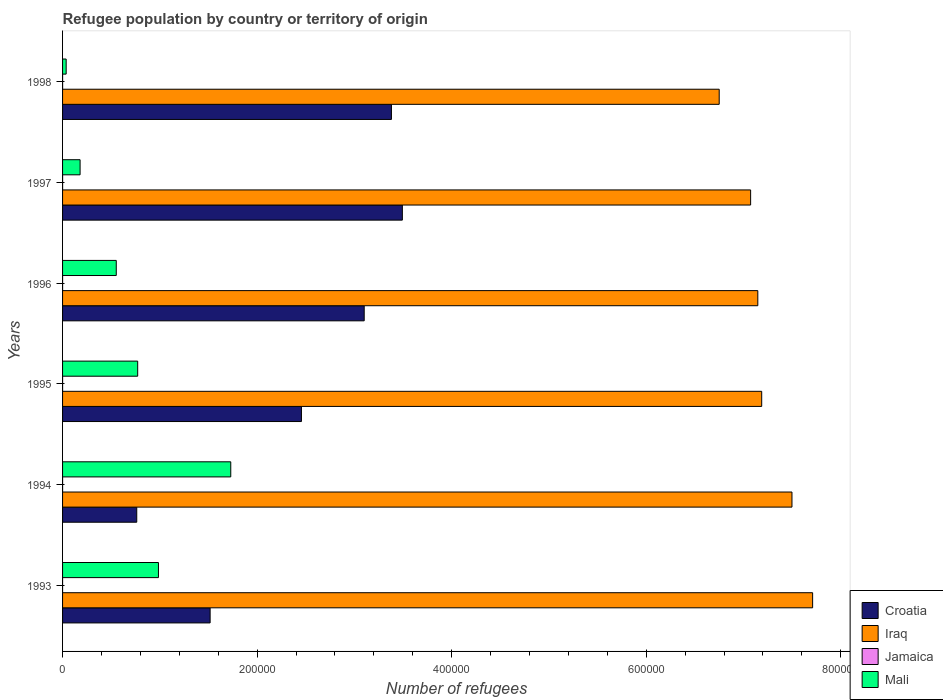How many different coloured bars are there?
Make the answer very short. 4. How many groups of bars are there?
Your answer should be compact. 6. Are the number of bars per tick equal to the number of legend labels?
Offer a very short reply. Yes. Are the number of bars on each tick of the Y-axis equal?
Your response must be concise. Yes. In how many cases, is the number of bars for a given year not equal to the number of legend labels?
Your response must be concise. 0. What is the number of refugees in Jamaica in 1993?
Make the answer very short. 3. Across all years, what is the maximum number of refugees in Iraq?
Your answer should be compact. 7.71e+05. Across all years, what is the minimum number of refugees in Croatia?
Your answer should be compact. 7.63e+04. What is the total number of refugees in Mali in the graph?
Provide a succinct answer. 4.26e+05. What is the difference between the number of refugees in Jamaica in 1997 and that in 1998?
Your response must be concise. -6. What is the difference between the number of refugees in Jamaica in 1996 and the number of refugees in Mali in 1998?
Provide a succinct answer. -3684. What is the average number of refugees in Iraq per year?
Give a very brief answer. 7.23e+05. In the year 1995, what is the difference between the number of refugees in Mali and number of refugees in Croatia?
Make the answer very short. -1.68e+05. In how many years, is the number of refugees in Iraq greater than 760000 ?
Your answer should be compact. 1. What is the ratio of the number of refugees in Croatia in 1993 to that in 1995?
Provide a succinct answer. 0.62. Is the number of refugees in Iraq in 1993 less than that in 1997?
Offer a very short reply. No. Is the difference between the number of refugees in Mali in 1993 and 1994 greater than the difference between the number of refugees in Croatia in 1993 and 1994?
Provide a short and direct response. No. What is the difference between the highest and the lowest number of refugees in Croatia?
Keep it short and to the point. 2.73e+05. Is the sum of the number of refugees in Croatia in 1995 and 1997 greater than the maximum number of refugees in Mali across all years?
Ensure brevity in your answer.  Yes. Is it the case that in every year, the sum of the number of refugees in Iraq and number of refugees in Croatia is greater than the sum of number of refugees in Jamaica and number of refugees in Mali?
Offer a very short reply. Yes. What does the 2nd bar from the top in 1993 represents?
Ensure brevity in your answer.  Jamaica. What does the 2nd bar from the bottom in 1993 represents?
Make the answer very short. Iraq. Is it the case that in every year, the sum of the number of refugees in Mali and number of refugees in Jamaica is greater than the number of refugees in Iraq?
Offer a very short reply. No. Are the values on the major ticks of X-axis written in scientific E-notation?
Offer a very short reply. No. Where does the legend appear in the graph?
Your answer should be very brief. Bottom right. How many legend labels are there?
Give a very brief answer. 4. What is the title of the graph?
Your answer should be very brief. Refugee population by country or territory of origin. What is the label or title of the X-axis?
Your answer should be very brief. Number of refugees. What is the label or title of the Y-axis?
Offer a very short reply. Years. What is the Number of refugees of Croatia in 1993?
Keep it short and to the point. 1.52e+05. What is the Number of refugees in Iraq in 1993?
Provide a short and direct response. 7.71e+05. What is the Number of refugees in Jamaica in 1993?
Give a very brief answer. 3. What is the Number of refugees of Mali in 1993?
Make the answer very short. 9.86e+04. What is the Number of refugees of Croatia in 1994?
Your answer should be very brief. 7.63e+04. What is the Number of refugees of Iraq in 1994?
Offer a terse response. 7.50e+05. What is the Number of refugees in Jamaica in 1994?
Ensure brevity in your answer.  7. What is the Number of refugees in Mali in 1994?
Offer a terse response. 1.73e+05. What is the Number of refugees of Croatia in 1995?
Your answer should be very brief. 2.46e+05. What is the Number of refugees in Iraq in 1995?
Keep it short and to the point. 7.19e+05. What is the Number of refugees in Jamaica in 1995?
Your answer should be compact. 10. What is the Number of refugees in Mali in 1995?
Offer a terse response. 7.72e+04. What is the Number of refugees in Croatia in 1996?
Give a very brief answer. 3.10e+05. What is the Number of refugees of Iraq in 1996?
Your answer should be very brief. 7.15e+05. What is the Number of refugees of Jamaica in 1996?
Give a very brief answer. 18. What is the Number of refugees in Mali in 1996?
Your response must be concise. 5.52e+04. What is the Number of refugees of Croatia in 1997?
Your answer should be compact. 3.49e+05. What is the Number of refugees in Iraq in 1997?
Provide a short and direct response. 7.07e+05. What is the Number of refugees of Jamaica in 1997?
Give a very brief answer. 21. What is the Number of refugees of Mali in 1997?
Your answer should be very brief. 1.80e+04. What is the Number of refugees in Croatia in 1998?
Your answer should be compact. 3.38e+05. What is the Number of refugees of Iraq in 1998?
Provide a succinct answer. 6.75e+05. What is the Number of refugees of Jamaica in 1998?
Offer a very short reply. 27. What is the Number of refugees of Mali in 1998?
Give a very brief answer. 3702. Across all years, what is the maximum Number of refugees of Croatia?
Your response must be concise. 3.49e+05. Across all years, what is the maximum Number of refugees in Iraq?
Your answer should be compact. 7.71e+05. Across all years, what is the maximum Number of refugees in Mali?
Keep it short and to the point. 1.73e+05. Across all years, what is the minimum Number of refugees of Croatia?
Offer a very short reply. 7.63e+04. Across all years, what is the minimum Number of refugees of Iraq?
Keep it short and to the point. 6.75e+05. Across all years, what is the minimum Number of refugees of Jamaica?
Keep it short and to the point. 3. Across all years, what is the minimum Number of refugees of Mali?
Ensure brevity in your answer.  3702. What is the total Number of refugees in Croatia in the graph?
Your answer should be compact. 1.47e+06. What is the total Number of refugees of Iraq in the graph?
Provide a succinct answer. 4.34e+06. What is the total Number of refugees of Mali in the graph?
Provide a short and direct response. 4.26e+05. What is the difference between the Number of refugees in Croatia in 1993 and that in 1994?
Your answer should be compact. 7.54e+04. What is the difference between the Number of refugees in Iraq in 1993 and that in 1994?
Your answer should be compact. 2.12e+04. What is the difference between the Number of refugees in Jamaica in 1993 and that in 1994?
Your answer should be very brief. -4. What is the difference between the Number of refugees in Mali in 1993 and that in 1994?
Offer a very short reply. -7.43e+04. What is the difference between the Number of refugees in Croatia in 1993 and that in 1995?
Provide a succinct answer. -9.39e+04. What is the difference between the Number of refugees of Iraq in 1993 and that in 1995?
Your answer should be compact. 5.24e+04. What is the difference between the Number of refugees in Jamaica in 1993 and that in 1995?
Your response must be concise. -7. What is the difference between the Number of refugees of Mali in 1993 and that in 1995?
Give a very brief answer. 2.14e+04. What is the difference between the Number of refugees of Croatia in 1993 and that in 1996?
Your answer should be very brief. -1.58e+05. What is the difference between the Number of refugees in Iraq in 1993 and that in 1996?
Offer a very short reply. 5.63e+04. What is the difference between the Number of refugees in Jamaica in 1993 and that in 1996?
Make the answer very short. -15. What is the difference between the Number of refugees of Mali in 1993 and that in 1996?
Your answer should be compact. 4.34e+04. What is the difference between the Number of refugees of Croatia in 1993 and that in 1997?
Keep it short and to the point. -1.98e+05. What is the difference between the Number of refugees in Iraq in 1993 and that in 1997?
Offer a very short reply. 6.37e+04. What is the difference between the Number of refugees of Mali in 1993 and that in 1997?
Give a very brief answer. 8.06e+04. What is the difference between the Number of refugees in Croatia in 1993 and that in 1998?
Give a very brief answer. -1.86e+05. What is the difference between the Number of refugees of Iraq in 1993 and that in 1998?
Offer a very short reply. 9.60e+04. What is the difference between the Number of refugees in Mali in 1993 and that in 1998?
Your response must be concise. 9.49e+04. What is the difference between the Number of refugees in Croatia in 1994 and that in 1995?
Provide a short and direct response. -1.69e+05. What is the difference between the Number of refugees in Iraq in 1994 and that in 1995?
Make the answer very short. 3.11e+04. What is the difference between the Number of refugees of Jamaica in 1994 and that in 1995?
Give a very brief answer. -3. What is the difference between the Number of refugees in Mali in 1994 and that in 1995?
Offer a terse response. 9.57e+04. What is the difference between the Number of refugees in Croatia in 1994 and that in 1996?
Make the answer very short. -2.34e+05. What is the difference between the Number of refugees of Iraq in 1994 and that in 1996?
Provide a succinct answer. 3.51e+04. What is the difference between the Number of refugees of Jamaica in 1994 and that in 1996?
Your response must be concise. -11. What is the difference between the Number of refugees of Mali in 1994 and that in 1996?
Your answer should be compact. 1.18e+05. What is the difference between the Number of refugees of Croatia in 1994 and that in 1997?
Offer a very short reply. -2.73e+05. What is the difference between the Number of refugees of Iraq in 1994 and that in 1997?
Provide a succinct answer. 4.25e+04. What is the difference between the Number of refugees in Mali in 1994 and that in 1997?
Your answer should be compact. 1.55e+05. What is the difference between the Number of refugees of Croatia in 1994 and that in 1998?
Offer a very short reply. -2.62e+05. What is the difference between the Number of refugees of Iraq in 1994 and that in 1998?
Keep it short and to the point. 7.48e+04. What is the difference between the Number of refugees in Jamaica in 1994 and that in 1998?
Give a very brief answer. -20. What is the difference between the Number of refugees of Mali in 1994 and that in 1998?
Provide a short and direct response. 1.69e+05. What is the difference between the Number of refugees of Croatia in 1995 and that in 1996?
Ensure brevity in your answer.  -6.45e+04. What is the difference between the Number of refugees in Iraq in 1995 and that in 1996?
Make the answer very short. 3989. What is the difference between the Number of refugees of Jamaica in 1995 and that in 1996?
Give a very brief answer. -8. What is the difference between the Number of refugees of Mali in 1995 and that in 1996?
Ensure brevity in your answer.  2.20e+04. What is the difference between the Number of refugees of Croatia in 1995 and that in 1997?
Provide a succinct answer. -1.04e+05. What is the difference between the Number of refugees in Iraq in 1995 and that in 1997?
Offer a terse response. 1.14e+04. What is the difference between the Number of refugees in Mali in 1995 and that in 1997?
Keep it short and to the point. 5.92e+04. What is the difference between the Number of refugees of Croatia in 1995 and that in 1998?
Your answer should be compact. -9.25e+04. What is the difference between the Number of refugees of Iraq in 1995 and that in 1998?
Ensure brevity in your answer.  4.37e+04. What is the difference between the Number of refugees in Mali in 1995 and that in 1998?
Ensure brevity in your answer.  7.35e+04. What is the difference between the Number of refugees in Croatia in 1996 and that in 1997?
Make the answer very short. -3.92e+04. What is the difference between the Number of refugees in Iraq in 1996 and that in 1997?
Provide a short and direct response. 7392. What is the difference between the Number of refugees in Mali in 1996 and that in 1997?
Your response must be concise. 3.72e+04. What is the difference between the Number of refugees of Croatia in 1996 and that in 1998?
Your response must be concise. -2.80e+04. What is the difference between the Number of refugees in Iraq in 1996 and that in 1998?
Your answer should be very brief. 3.97e+04. What is the difference between the Number of refugees in Mali in 1996 and that in 1998?
Provide a short and direct response. 5.15e+04. What is the difference between the Number of refugees of Croatia in 1997 and that in 1998?
Your answer should be very brief. 1.12e+04. What is the difference between the Number of refugees of Iraq in 1997 and that in 1998?
Keep it short and to the point. 3.23e+04. What is the difference between the Number of refugees of Mali in 1997 and that in 1998?
Make the answer very short. 1.43e+04. What is the difference between the Number of refugees of Croatia in 1993 and the Number of refugees of Iraq in 1994?
Ensure brevity in your answer.  -5.98e+05. What is the difference between the Number of refugees of Croatia in 1993 and the Number of refugees of Jamaica in 1994?
Your response must be concise. 1.52e+05. What is the difference between the Number of refugees in Croatia in 1993 and the Number of refugees in Mali in 1994?
Provide a short and direct response. -2.12e+04. What is the difference between the Number of refugees in Iraq in 1993 and the Number of refugees in Jamaica in 1994?
Make the answer very short. 7.71e+05. What is the difference between the Number of refugees in Iraq in 1993 and the Number of refugees in Mali in 1994?
Give a very brief answer. 5.98e+05. What is the difference between the Number of refugees of Jamaica in 1993 and the Number of refugees of Mali in 1994?
Keep it short and to the point. -1.73e+05. What is the difference between the Number of refugees in Croatia in 1993 and the Number of refugees in Iraq in 1995?
Offer a terse response. -5.67e+05. What is the difference between the Number of refugees in Croatia in 1993 and the Number of refugees in Jamaica in 1995?
Your answer should be very brief. 1.52e+05. What is the difference between the Number of refugees in Croatia in 1993 and the Number of refugees in Mali in 1995?
Offer a very short reply. 7.45e+04. What is the difference between the Number of refugees in Iraq in 1993 and the Number of refugees in Jamaica in 1995?
Provide a succinct answer. 7.71e+05. What is the difference between the Number of refugees of Iraq in 1993 and the Number of refugees of Mali in 1995?
Offer a very short reply. 6.94e+05. What is the difference between the Number of refugees in Jamaica in 1993 and the Number of refugees in Mali in 1995?
Keep it short and to the point. -7.72e+04. What is the difference between the Number of refugees of Croatia in 1993 and the Number of refugees of Iraq in 1996?
Give a very brief answer. -5.63e+05. What is the difference between the Number of refugees of Croatia in 1993 and the Number of refugees of Jamaica in 1996?
Your response must be concise. 1.52e+05. What is the difference between the Number of refugees of Croatia in 1993 and the Number of refugees of Mali in 1996?
Offer a very short reply. 9.65e+04. What is the difference between the Number of refugees in Iraq in 1993 and the Number of refugees in Jamaica in 1996?
Provide a succinct answer. 7.71e+05. What is the difference between the Number of refugees in Iraq in 1993 and the Number of refugees in Mali in 1996?
Give a very brief answer. 7.16e+05. What is the difference between the Number of refugees in Jamaica in 1993 and the Number of refugees in Mali in 1996?
Your response must be concise. -5.52e+04. What is the difference between the Number of refugees of Croatia in 1993 and the Number of refugees of Iraq in 1997?
Ensure brevity in your answer.  -5.56e+05. What is the difference between the Number of refugees in Croatia in 1993 and the Number of refugees in Jamaica in 1997?
Provide a succinct answer. 1.52e+05. What is the difference between the Number of refugees of Croatia in 1993 and the Number of refugees of Mali in 1997?
Offer a terse response. 1.34e+05. What is the difference between the Number of refugees in Iraq in 1993 and the Number of refugees in Jamaica in 1997?
Provide a succinct answer. 7.71e+05. What is the difference between the Number of refugees of Iraq in 1993 and the Number of refugees of Mali in 1997?
Your answer should be very brief. 7.53e+05. What is the difference between the Number of refugees in Jamaica in 1993 and the Number of refugees in Mali in 1997?
Your answer should be very brief. -1.80e+04. What is the difference between the Number of refugees of Croatia in 1993 and the Number of refugees of Iraq in 1998?
Your response must be concise. -5.23e+05. What is the difference between the Number of refugees of Croatia in 1993 and the Number of refugees of Jamaica in 1998?
Offer a very short reply. 1.52e+05. What is the difference between the Number of refugees in Croatia in 1993 and the Number of refugees in Mali in 1998?
Offer a terse response. 1.48e+05. What is the difference between the Number of refugees of Iraq in 1993 and the Number of refugees of Jamaica in 1998?
Make the answer very short. 7.71e+05. What is the difference between the Number of refugees in Iraq in 1993 and the Number of refugees in Mali in 1998?
Give a very brief answer. 7.67e+05. What is the difference between the Number of refugees in Jamaica in 1993 and the Number of refugees in Mali in 1998?
Offer a very short reply. -3699. What is the difference between the Number of refugees of Croatia in 1994 and the Number of refugees of Iraq in 1995?
Your response must be concise. -6.42e+05. What is the difference between the Number of refugees in Croatia in 1994 and the Number of refugees in Jamaica in 1995?
Your response must be concise. 7.62e+04. What is the difference between the Number of refugees of Croatia in 1994 and the Number of refugees of Mali in 1995?
Provide a succinct answer. -963. What is the difference between the Number of refugees in Iraq in 1994 and the Number of refugees in Jamaica in 1995?
Your answer should be very brief. 7.50e+05. What is the difference between the Number of refugees of Iraq in 1994 and the Number of refugees of Mali in 1995?
Your answer should be very brief. 6.73e+05. What is the difference between the Number of refugees in Jamaica in 1994 and the Number of refugees in Mali in 1995?
Your response must be concise. -7.72e+04. What is the difference between the Number of refugees in Croatia in 1994 and the Number of refugees in Iraq in 1996?
Your response must be concise. -6.38e+05. What is the difference between the Number of refugees in Croatia in 1994 and the Number of refugees in Jamaica in 1996?
Offer a very short reply. 7.62e+04. What is the difference between the Number of refugees in Croatia in 1994 and the Number of refugees in Mali in 1996?
Your answer should be compact. 2.11e+04. What is the difference between the Number of refugees in Iraq in 1994 and the Number of refugees in Jamaica in 1996?
Make the answer very short. 7.50e+05. What is the difference between the Number of refugees in Iraq in 1994 and the Number of refugees in Mali in 1996?
Keep it short and to the point. 6.95e+05. What is the difference between the Number of refugees in Jamaica in 1994 and the Number of refugees in Mali in 1996?
Provide a short and direct response. -5.52e+04. What is the difference between the Number of refugees in Croatia in 1994 and the Number of refugees in Iraq in 1997?
Ensure brevity in your answer.  -6.31e+05. What is the difference between the Number of refugees in Croatia in 1994 and the Number of refugees in Jamaica in 1997?
Keep it short and to the point. 7.62e+04. What is the difference between the Number of refugees in Croatia in 1994 and the Number of refugees in Mali in 1997?
Provide a succinct answer. 5.82e+04. What is the difference between the Number of refugees of Iraq in 1994 and the Number of refugees of Jamaica in 1997?
Keep it short and to the point. 7.50e+05. What is the difference between the Number of refugees in Iraq in 1994 and the Number of refugees in Mali in 1997?
Provide a short and direct response. 7.32e+05. What is the difference between the Number of refugees of Jamaica in 1994 and the Number of refugees of Mali in 1997?
Provide a succinct answer. -1.80e+04. What is the difference between the Number of refugees of Croatia in 1994 and the Number of refugees of Iraq in 1998?
Provide a succinct answer. -5.99e+05. What is the difference between the Number of refugees in Croatia in 1994 and the Number of refugees in Jamaica in 1998?
Your response must be concise. 7.62e+04. What is the difference between the Number of refugees in Croatia in 1994 and the Number of refugees in Mali in 1998?
Make the answer very short. 7.26e+04. What is the difference between the Number of refugees of Iraq in 1994 and the Number of refugees of Jamaica in 1998?
Give a very brief answer. 7.50e+05. What is the difference between the Number of refugees of Iraq in 1994 and the Number of refugees of Mali in 1998?
Your response must be concise. 7.46e+05. What is the difference between the Number of refugees of Jamaica in 1994 and the Number of refugees of Mali in 1998?
Provide a succinct answer. -3695. What is the difference between the Number of refugees in Croatia in 1995 and the Number of refugees in Iraq in 1996?
Keep it short and to the point. -4.69e+05. What is the difference between the Number of refugees in Croatia in 1995 and the Number of refugees in Jamaica in 1996?
Make the answer very short. 2.46e+05. What is the difference between the Number of refugees of Croatia in 1995 and the Number of refugees of Mali in 1996?
Provide a short and direct response. 1.90e+05. What is the difference between the Number of refugees in Iraq in 1995 and the Number of refugees in Jamaica in 1996?
Your response must be concise. 7.19e+05. What is the difference between the Number of refugees of Iraq in 1995 and the Number of refugees of Mali in 1996?
Give a very brief answer. 6.64e+05. What is the difference between the Number of refugees of Jamaica in 1995 and the Number of refugees of Mali in 1996?
Keep it short and to the point. -5.52e+04. What is the difference between the Number of refugees in Croatia in 1995 and the Number of refugees in Iraq in 1997?
Ensure brevity in your answer.  -4.62e+05. What is the difference between the Number of refugees in Croatia in 1995 and the Number of refugees in Jamaica in 1997?
Make the answer very short. 2.46e+05. What is the difference between the Number of refugees in Croatia in 1995 and the Number of refugees in Mali in 1997?
Provide a succinct answer. 2.28e+05. What is the difference between the Number of refugees in Iraq in 1995 and the Number of refugees in Jamaica in 1997?
Give a very brief answer. 7.19e+05. What is the difference between the Number of refugees of Iraq in 1995 and the Number of refugees of Mali in 1997?
Your answer should be very brief. 7.01e+05. What is the difference between the Number of refugees in Jamaica in 1995 and the Number of refugees in Mali in 1997?
Give a very brief answer. -1.80e+04. What is the difference between the Number of refugees in Croatia in 1995 and the Number of refugees in Iraq in 1998?
Give a very brief answer. -4.29e+05. What is the difference between the Number of refugees in Croatia in 1995 and the Number of refugees in Jamaica in 1998?
Keep it short and to the point. 2.46e+05. What is the difference between the Number of refugees in Croatia in 1995 and the Number of refugees in Mali in 1998?
Provide a succinct answer. 2.42e+05. What is the difference between the Number of refugees in Iraq in 1995 and the Number of refugees in Jamaica in 1998?
Your answer should be compact. 7.19e+05. What is the difference between the Number of refugees of Iraq in 1995 and the Number of refugees of Mali in 1998?
Provide a short and direct response. 7.15e+05. What is the difference between the Number of refugees in Jamaica in 1995 and the Number of refugees in Mali in 1998?
Keep it short and to the point. -3692. What is the difference between the Number of refugees in Croatia in 1996 and the Number of refugees in Iraq in 1997?
Offer a terse response. -3.97e+05. What is the difference between the Number of refugees in Croatia in 1996 and the Number of refugees in Jamaica in 1997?
Provide a short and direct response. 3.10e+05. What is the difference between the Number of refugees in Croatia in 1996 and the Number of refugees in Mali in 1997?
Give a very brief answer. 2.92e+05. What is the difference between the Number of refugees of Iraq in 1996 and the Number of refugees of Jamaica in 1997?
Provide a short and direct response. 7.15e+05. What is the difference between the Number of refugees of Iraq in 1996 and the Number of refugees of Mali in 1997?
Your response must be concise. 6.97e+05. What is the difference between the Number of refugees in Jamaica in 1996 and the Number of refugees in Mali in 1997?
Ensure brevity in your answer.  -1.80e+04. What is the difference between the Number of refugees in Croatia in 1996 and the Number of refugees in Iraq in 1998?
Your answer should be very brief. -3.65e+05. What is the difference between the Number of refugees of Croatia in 1996 and the Number of refugees of Jamaica in 1998?
Provide a short and direct response. 3.10e+05. What is the difference between the Number of refugees in Croatia in 1996 and the Number of refugees in Mali in 1998?
Make the answer very short. 3.06e+05. What is the difference between the Number of refugees of Iraq in 1996 and the Number of refugees of Jamaica in 1998?
Ensure brevity in your answer.  7.15e+05. What is the difference between the Number of refugees in Iraq in 1996 and the Number of refugees in Mali in 1998?
Offer a very short reply. 7.11e+05. What is the difference between the Number of refugees in Jamaica in 1996 and the Number of refugees in Mali in 1998?
Your response must be concise. -3684. What is the difference between the Number of refugees of Croatia in 1997 and the Number of refugees of Iraq in 1998?
Give a very brief answer. -3.26e+05. What is the difference between the Number of refugees of Croatia in 1997 and the Number of refugees of Jamaica in 1998?
Keep it short and to the point. 3.49e+05. What is the difference between the Number of refugees of Croatia in 1997 and the Number of refugees of Mali in 1998?
Your answer should be compact. 3.46e+05. What is the difference between the Number of refugees of Iraq in 1997 and the Number of refugees of Jamaica in 1998?
Offer a terse response. 7.07e+05. What is the difference between the Number of refugees of Iraq in 1997 and the Number of refugees of Mali in 1998?
Make the answer very short. 7.04e+05. What is the difference between the Number of refugees in Jamaica in 1997 and the Number of refugees in Mali in 1998?
Ensure brevity in your answer.  -3681. What is the average Number of refugees of Croatia per year?
Your answer should be very brief. 2.45e+05. What is the average Number of refugees in Iraq per year?
Provide a succinct answer. 7.23e+05. What is the average Number of refugees of Jamaica per year?
Offer a very short reply. 14.33. What is the average Number of refugees in Mali per year?
Make the answer very short. 7.09e+04. In the year 1993, what is the difference between the Number of refugees of Croatia and Number of refugees of Iraq?
Offer a terse response. -6.19e+05. In the year 1993, what is the difference between the Number of refugees of Croatia and Number of refugees of Jamaica?
Ensure brevity in your answer.  1.52e+05. In the year 1993, what is the difference between the Number of refugees of Croatia and Number of refugees of Mali?
Give a very brief answer. 5.31e+04. In the year 1993, what is the difference between the Number of refugees in Iraq and Number of refugees in Jamaica?
Your answer should be compact. 7.71e+05. In the year 1993, what is the difference between the Number of refugees of Iraq and Number of refugees of Mali?
Offer a terse response. 6.73e+05. In the year 1993, what is the difference between the Number of refugees in Jamaica and Number of refugees in Mali?
Make the answer very short. -9.86e+04. In the year 1994, what is the difference between the Number of refugees of Croatia and Number of refugees of Iraq?
Offer a very short reply. -6.74e+05. In the year 1994, what is the difference between the Number of refugees in Croatia and Number of refugees in Jamaica?
Offer a very short reply. 7.62e+04. In the year 1994, what is the difference between the Number of refugees of Croatia and Number of refugees of Mali?
Offer a terse response. -9.66e+04. In the year 1994, what is the difference between the Number of refugees in Iraq and Number of refugees in Jamaica?
Your answer should be very brief. 7.50e+05. In the year 1994, what is the difference between the Number of refugees of Iraq and Number of refugees of Mali?
Ensure brevity in your answer.  5.77e+05. In the year 1994, what is the difference between the Number of refugees of Jamaica and Number of refugees of Mali?
Your answer should be very brief. -1.73e+05. In the year 1995, what is the difference between the Number of refugees in Croatia and Number of refugees in Iraq?
Provide a succinct answer. -4.73e+05. In the year 1995, what is the difference between the Number of refugees in Croatia and Number of refugees in Jamaica?
Offer a very short reply. 2.46e+05. In the year 1995, what is the difference between the Number of refugees in Croatia and Number of refugees in Mali?
Give a very brief answer. 1.68e+05. In the year 1995, what is the difference between the Number of refugees of Iraq and Number of refugees of Jamaica?
Provide a short and direct response. 7.19e+05. In the year 1995, what is the difference between the Number of refugees of Iraq and Number of refugees of Mali?
Provide a short and direct response. 6.42e+05. In the year 1995, what is the difference between the Number of refugees in Jamaica and Number of refugees in Mali?
Offer a terse response. -7.72e+04. In the year 1996, what is the difference between the Number of refugees of Croatia and Number of refugees of Iraq?
Offer a terse response. -4.05e+05. In the year 1996, what is the difference between the Number of refugees in Croatia and Number of refugees in Jamaica?
Keep it short and to the point. 3.10e+05. In the year 1996, what is the difference between the Number of refugees in Croatia and Number of refugees in Mali?
Give a very brief answer. 2.55e+05. In the year 1996, what is the difference between the Number of refugees of Iraq and Number of refugees of Jamaica?
Give a very brief answer. 7.15e+05. In the year 1996, what is the difference between the Number of refugees in Iraq and Number of refugees in Mali?
Ensure brevity in your answer.  6.60e+05. In the year 1996, what is the difference between the Number of refugees of Jamaica and Number of refugees of Mali?
Offer a terse response. -5.52e+04. In the year 1997, what is the difference between the Number of refugees of Croatia and Number of refugees of Iraq?
Ensure brevity in your answer.  -3.58e+05. In the year 1997, what is the difference between the Number of refugees in Croatia and Number of refugees in Jamaica?
Keep it short and to the point. 3.49e+05. In the year 1997, what is the difference between the Number of refugees in Croatia and Number of refugees in Mali?
Provide a succinct answer. 3.31e+05. In the year 1997, what is the difference between the Number of refugees in Iraq and Number of refugees in Jamaica?
Provide a succinct answer. 7.07e+05. In the year 1997, what is the difference between the Number of refugees in Iraq and Number of refugees in Mali?
Offer a terse response. 6.89e+05. In the year 1997, what is the difference between the Number of refugees of Jamaica and Number of refugees of Mali?
Ensure brevity in your answer.  -1.80e+04. In the year 1998, what is the difference between the Number of refugees of Croatia and Number of refugees of Iraq?
Your response must be concise. -3.37e+05. In the year 1998, what is the difference between the Number of refugees in Croatia and Number of refugees in Jamaica?
Keep it short and to the point. 3.38e+05. In the year 1998, what is the difference between the Number of refugees of Croatia and Number of refugees of Mali?
Your response must be concise. 3.34e+05. In the year 1998, what is the difference between the Number of refugees of Iraq and Number of refugees of Jamaica?
Your answer should be compact. 6.75e+05. In the year 1998, what is the difference between the Number of refugees of Iraq and Number of refugees of Mali?
Provide a short and direct response. 6.71e+05. In the year 1998, what is the difference between the Number of refugees of Jamaica and Number of refugees of Mali?
Give a very brief answer. -3675. What is the ratio of the Number of refugees in Croatia in 1993 to that in 1994?
Keep it short and to the point. 1.99. What is the ratio of the Number of refugees of Iraq in 1993 to that in 1994?
Your answer should be very brief. 1.03. What is the ratio of the Number of refugees of Jamaica in 1993 to that in 1994?
Make the answer very short. 0.43. What is the ratio of the Number of refugees of Mali in 1993 to that in 1994?
Offer a terse response. 0.57. What is the ratio of the Number of refugees of Croatia in 1993 to that in 1995?
Offer a very short reply. 0.62. What is the ratio of the Number of refugees of Iraq in 1993 to that in 1995?
Ensure brevity in your answer.  1.07. What is the ratio of the Number of refugees of Mali in 1993 to that in 1995?
Offer a very short reply. 1.28. What is the ratio of the Number of refugees in Croatia in 1993 to that in 1996?
Provide a short and direct response. 0.49. What is the ratio of the Number of refugees in Iraq in 1993 to that in 1996?
Give a very brief answer. 1.08. What is the ratio of the Number of refugees of Jamaica in 1993 to that in 1996?
Your response must be concise. 0.17. What is the ratio of the Number of refugees in Mali in 1993 to that in 1996?
Your answer should be compact. 1.79. What is the ratio of the Number of refugees of Croatia in 1993 to that in 1997?
Ensure brevity in your answer.  0.43. What is the ratio of the Number of refugees of Iraq in 1993 to that in 1997?
Provide a short and direct response. 1.09. What is the ratio of the Number of refugees in Jamaica in 1993 to that in 1997?
Offer a very short reply. 0.14. What is the ratio of the Number of refugees of Mali in 1993 to that in 1997?
Offer a very short reply. 5.47. What is the ratio of the Number of refugees in Croatia in 1993 to that in 1998?
Your response must be concise. 0.45. What is the ratio of the Number of refugees of Iraq in 1993 to that in 1998?
Offer a terse response. 1.14. What is the ratio of the Number of refugees in Mali in 1993 to that in 1998?
Your answer should be compact. 26.63. What is the ratio of the Number of refugees of Croatia in 1994 to that in 1995?
Your answer should be very brief. 0.31. What is the ratio of the Number of refugees of Iraq in 1994 to that in 1995?
Give a very brief answer. 1.04. What is the ratio of the Number of refugees of Mali in 1994 to that in 1995?
Your answer should be compact. 2.24. What is the ratio of the Number of refugees of Croatia in 1994 to that in 1996?
Your answer should be compact. 0.25. What is the ratio of the Number of refugees in Iraq in 1994 to that in 1996?
Offer a terse response. 1.05. What is the ratio of the Number of refugees in Jamaica in 1994 to that in 1996?
Provide a short and direct response. 0.39. What is the ratio of the Number of refugees of Mali in 1994 to that in 1996?
Provide a short and direct response. 3.13. What is the ratio of the Number of refugees in Croatia in 1994 to that in 1997?
Offer a terse response. 0.22. What is the ratio of the Number of refugees of Iraq in 1994 to that in 1997?
Keep it short and to the point. 1.06. What is the ratio of the Number of refugees in Mali in 1994 to that in 1997?
Ensure brevity in your answer.  9.6. What is the ratio of the Number of refugees of Croatia in 1994 to that in 1998?
Your response must be concise. 0.23. What is the ratio of the Number of refugees in Iraq in 1994 to that in 1998?
Provide a succinct answer. 1.11. What is the ratio of the Number of refugees of Jamaica in 1994 to that in 1998?
Offer a terse response. 0.26. What is the ratio of the Number of refugees of Mali in 1994 to that in 1998?
Provide a succinct answer. 46.71. What is the ratio of the Number of refugees in Croatia in 1995 to that in 1996?
Ensure brevity in your answer.  0.79. What is the ratio of the Number of refugees of Iraq in 1995 to that in 1996?
Make the answer very short. 1.01. What is the ratio of the Number of refugees in Jamaica in 1995 to that in 1996?
Make the answer very short. 0.56. What is the ratio of the Number of refugees in Mali in 1995 to that in 1996?
Keep it short and to the point. 1.4. What is the ratio of the Number of refugees of Croatia in 1995 to that in 1997?
Give a very brief answer. 0.7. What is the ratio of the Number of refugees of Iraq in 1995 to that in 1997?
Make the answer very short. 1.02. What is the ratio of the Number of refugees in Jamaica in 1995 to that in 1997?
Provide a succinct answer. 0.48. What is the ratio of the Number of refugees in Mali in 1995 to that in 1997?
Your answer should be compact. 4.29. What is the ratio of the Number of refugees of Croatia in 1995 to that in 1998?
Offer a very short reply. 0.73. What is the ratio of the Number of refugees of Iraq in 1995 to that in 1998?
Make the answer very short. 1.06. What is the ratio of the Number of refugees in Jamaica in 1995 to that in 1998?
Ensure brevity in your answer.  0.37. What is the ratio of the Number of refugees of Mali in 1995 to that in 1998?
Keep it short and to the point. 20.86. What is the ratio of the Number of refugees of Croatia in 1996 to that in 1997?
Your answer should be compact. 0.89. What is the ratio of the Number of refugees of Iraq in 1996 to that in 1997?
Your response must be concise. 1.01. What is the ratio of the Number of refugees of Mali in 1996 to that in 1997?
Offer a very short reply. 3.06. What is the ratio of the Number of refugees in Croatia in 1996 to that in 1998?
Your response must be concise. 0.92. What is the ratio of the Number of refugees of Iraq in 1996 to that in 1998?
Provide a succinct answer. 1.06. What is the ratio of the Number of refugees in Mali in 1996 to that in 1998?
Make the answer very short. 14.91. What is the ratio of the Number of refugees of Croatia in 1997 to that in 1998?
Your answer should be very brief. 1.03. What is the ratio of the Number of refugees of Iraq in 1997 to that in 1998?
Your answer should be very brief. 1.05. What is the ratio of the Number of refugees in Mali in 1997 to that in 1998?
Provide a succinct answer. 4.87. What is the difference between the highest and the second highest Number of refugees of Croatia?
Provide a short and direct response. 1.12e+04. What is the difference between the highest and the second highest Number of refugees in Iraq?
Your response must be concise. 2.12e+04. What is the difference between the highest and the second highest Number of refugees in Mali?
Offer a very short reply. 7.43e+04. What is the difference between the highest and the lowest Number of refugees of Croatia?
Give a very brief answer. 2.73e+05. What is the difference between the highest and the lowest Number of refugees in Iraq?
Keep it short and to the point. 9.60e+04. What is the difference between the highest and the lowest Number of refugees of Mali?
Your answer should be very brief. 1.69e+05. 